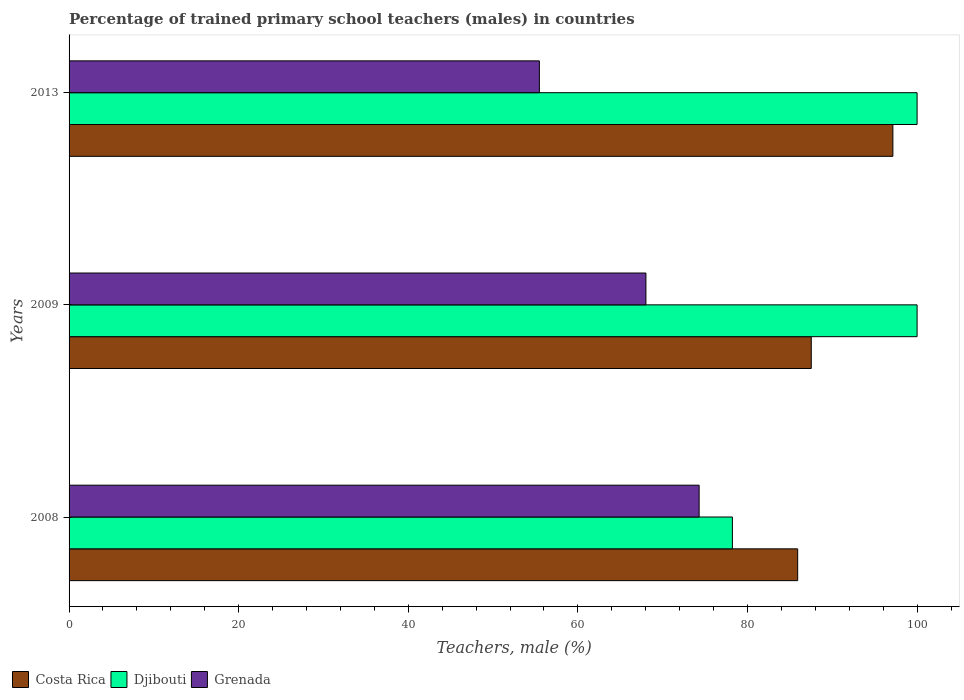How many groups of bars are there?
Your answer should be very brief. 3. Are the number of bars per tick equal to the number of legend labels?
Your response must be concise. Yes. In how many cases, is the number of bars for a given year not equal to the number of legend labels?
Your answer should be very brief. 0. What is the percentage of trained primary school teachers (males) in Costa Rica in 2009?
Make the answer very short. 87.52. Across all years, what is the maximum percentage of trained primary school teachers (males) in Grenada?
Offer a terse response. 74.3. Across all years, what is the minimum percentage of trained primary school teachers (males) in Djibouti?
Your answer should be compact. 78.22. In which year was the percentage of trained primary school teachers (males) in Djibouti maximum?
Keep it short and to the point. 2009. What is the total percentage of trained primary school teachers (males) in Costa Rica in the graph?
Ensure brevity in your answer.  270.58. What is the difference between the percentage of trained primary school teachers (males) in Costa Rica in 2008 and that in 2009?
Give a very brief answer. -1.6. What is the difference between the percentage of trained primary school teachers (males) in Costa Rica in 2009 and the percentage of trained primary school teachers (males) in Djibouti in 2008?
Offer a very short reply. 9.3. What is the average percentage of trained primary school teachers (males) in Costa Rica per year?
Provide a short and direct response. 90.19. In the year 2013, what is the difference between the percentage of trained primary school teachers (males) in Costa Rica and percentage of trained primary school teachers (males) in Grenada?
Provide a short and direct response. 41.68. What is the ratio of the percentage of trained primary school teachers (males) in Djibouti in 2008 to that in 2013?
Your response must be concise. 0.78. What is the difference between the highest and the lowest percentage of trained primary school teachers (males) in Costa Rica?
Provide a succinct answer. 11.23. In how many years, is the percentage of trained primary school teachers (males) in Costa Rica greater than the average percentage of trained primary school teachers (males) in Costa Rica taken over all years?
Your answer should be very brief. 1. What does the 2nd bar from the top in 2013 represents?
Give a very brief answer. Djibouti. What does the 2nd bar from the bottom in 2008 represents?
Make the answer very short. Djibouti. How many bars are there?
Make the answer very short. 9. What is the difference between two consecutive major ticks on the X-axis?
Your answer should be compact. 20. Does the graph contain any zero values?
Offer a very short reply. No. Does the graph contain grids?
Give a very brief answer. No. Where does the legend appear in the graph?
Keep it short and to the point. Bottom left. How many legend labels are there?
Keep it short and to the point. 3. How are the legend labels stacked?
Your answer should be compact. Horizontal. What is the title of the graph?
Your answer should be compact. Percentage of trained primary school teachers (males) in countries. What is the label or title of the X-axis?
Keep it short and to the point. Teachers, male (%). What is the label or title of the Y-axis?
Provide a short and direct response. Years. What is the Teachers, male (%) in Costa Rica in 2008?
Provide a succinct answer. 85.92. What is the Teachers, male (%) in Djibouti in 2008?
Make the answer very short. 78.22. What is the Teachers, male (%) in Grenada in 2008?
Your response must be concise. 74.3. What is the Teachers, male (%) in Costa Rica in 2009?
Provide a succinct answer. 87.52. What is the Teachers, male (%) of Djibouti in 2009?
Offer a terse response. 100. What is the Teachers, male (%) in Grenada in 2009?
Your answer should be very brief. 68.02. What is the Teachers, male (%) in Costa Rica in 2013?
Provide a succinct answer. 97.14. What is the Teachers, male (%) of Djibouti in 2013?
Make the answer very short. 100. What is the Teachers, male (%) in Grenada in 2013?
Your answer should be compact. 55.46. Across all years, what is the maximum Teachers, male (%) of Costa Rica?
Keep it short and to the point. 97.14. Across all years, what is the maximum Teachers, male (%) of Grenada?
Your answer should be very brief. 74.3. Across all years, what is the minimum Teachers, male (%) of Costa Rica?
Provide a succinct answer. 85.92. Across all years, what is the minimum Teachers, male (%) of Djibouti?
Provide a succinct answer. 78.22. Across all years, what is the minimum Teachers, male (%) of Grenada?
Make the answer very short. 55.46. What is the total Teachers, male (%) in Costa Rica in the graph?
Your response must be concise. 270.58. What is the total Teachers, male (%) in Djibouti in the graph?
Your answer should be compact. 278.22. What is the total Teachers, male (%) of Grenada in the graph?
Provide a succinct answer. 197.78. What is the difference between the Teachers, male (%) in Costa Rica in 2008 and that in 2009?
Keep it short and to the point. -1.6. What is the difference between the Teachers, male (%) of Djibouti in 2008 and that in 2009?
Ensure brevity in your answer.  -21.78. What is the difference between the Teachers, male (%) of Grenada in 2008 and that in 2009?
Your answer should be compact. 6.27. What is the difference between the Teachers, male (%) in Costa Rica in 2008 and that in 2013?
Provide a short and direct response. -11.23. What is the difference between the Teachers, male (%) in Djibouti in 2008 and that in 2013?
Ensure brevity in your answer.  -21.78. What is the difference between the Teachers, male (%) in Grenada in 2008 and that in 2013?
Provide a succinct answer. 18.84. What is the difference between the Teachers, male (%) of Costa Rica in 2009 and that in 2013?
Give a very brief answer. -9.62. What is the difference between the Teachers, male (%) in Djibouti in 2009 and that in 2013?
Ensure brevity in your answer.  0. What is the difference between the Teachers, male (%) in Grenada in 2009 and that in 2013?
Offer a very short reply. 12.56. What is the difference between the Teachers, male (%) in Costa Rica in 2008 and the Teachers, male (%) in Djibouti in 2009?
Offer a terse response. -14.08. What is the difference between the Teachers, male (%) in Costa Rica in 2008 and the Teachers, male (%) in Grenada in 2009?
Your answer should be compact. 17.89. What is the difference between the Teachers, male (%) in Djibouti in 2008 and the Teachers, male (%) in Grenada in 2009?
Your response must be concise. 10.2. What is the difference between the Teachers, male (%) of Costa Rica in 2008 and the Teachers, male (%) of Djibouti in 2013?
Your answer should be compact. -14.08. What is the difference between the Teachers, male (%) in Costa Rica in 2008 and the Teachers, male (%) in Grenada in 2013?
Your answer should be compact. 30.46. What is the difference between the Teachers, male (%) of Djibouti in 2008 and the Teachers, male (%) of Grenada in 2013?
Keep it short and to the point. 22.76. What is the difference between the Teachers, male (%) of Costa Rica in 2009 and the Teachers, male (%) of Djibouti in 2013?
Your answer should be compact. -12.48. What is the difference between the Teachers, male (%) of Costa Rica in 2009 and the Teachers, male (%) of Grenada in 2013?
Your answer should be very brief. 32.06. What is the difference between the Teachers, male (%) in Djibouti in 2009 and the Teachers, male (%) in Grenada in 2013?
Ensure brevity in your answer.  44.54. What is the average Teachers, male (%) of Costa Rica per year?
Provide a short and direct response. 90.19. What is the average Teachers, male (%) in Djibouti per year?
Ensure brevity in your answer.  92.74. What is the average Teachers, male (%) of Grenada per year?
Keep it short and to the point. 65.93. In the year 2008, what is the difference between the Teachers, male (%) in Costa Rica and Teachers, male (%) in Djibouti?
Your answer should be compact. 7.7. In the year 2008, what is the difference between the Teachers, male (%) of Costa Rica and Teachers, male (%) of Grenada?
Your answer should be very brief. 11.62. In the year 2008, what is the difference between the Teachers, male (%) in Djibouti and Teachers, male (%) in Grenada?
Provide a short and direct response. 3.92. In the year 2009, what is the difference between the Teachers, male (%) in Costa Rica and Teachers, male (%) in Djibouti?
Your answer should be compact. -12.48. In the year 2009, what is the difference between the Teachers, male (%) of Costa Rica and Teachers, male (%) of Grenada?
Offer a very short reply. 19.5. In the year 2009, what is the difference between the Teachers, male (%) of Djibouti and Teachers, male (%) of Grenada?
Make the answer very short. 31.98. In the year 2013, what is the difference between the Teachers, male (%) of Costa Rica and Teachers, male (%) of Djibouti?
Offer a very short reply. -2.86. In the year 2013, what is the difference between the Teachers, male (%) in Costa Rica and Teachers, male (%) in Grenada?
Your answer should be compact. 41.68. In the year 2013, what is the difference between the Teachers, male (%) in Djibouti and Teachers, male (%) in Grenada?
Keep it short and to the point. 44.54. What is the ratio of the Teachers, male (%) of Costa Rica in 2008 to that in 2009?
Your response must be concise. 0.98. What is the ratio of the Teachers, male (%) in Djibouti in 2008 to that in 2009?
Provide a short and direct response. 0.78. What is the ratio of the Teachers, male (%) of Grenada in 2008 to that in 2009?
Offer a terse response. 1.09. What is the ratio of the Teachers, male (%) in Costa Rica in 2008 to that in 2013?
Offer a terse response. 0.88. What is the ratio of the Teachers, male (%) of Djibouti in 2008 to that in 2013?
Your answer should be very brief. 0.78. What is the ratio of the Teachers, male (%) in Grenada in 2008 to that in 2013?
Make the answer very short. 1.34. What is the ratio of the Teachers, male (%) in Costa Rica in 2009 to that in 2013?
Offer a terse response. 0.9. What is the ratio of the Teachers, male (%) of Djibouti in 2009 to that in 2013?
Provide a short and direct response. 1. What is the ratio of the Teachers, male (%) of Grenada in 2009 to that in 2013?
Keep it short and to the point. 1.23. What is the difference between the highest and the second highest Teachers, male (%) of Costa Rica?
Keep it short and to the point. 9.62. What is the difference between the highest and the second highest Teachers, male (%) of Djibouti?
Offer a very short reply. 0. What is the difference between the highest and the second highest Teachers, male (%) in Grenada?
Your answer should be very brief. 6.27. What is the difference between the highest and the lowest Teachers, male (%) in Costa Rica?
Your answer should be compact. 11.23. What is the difference between the highest and the lowest Teachers, male (%) in Djibouti?
Offer a very short reply. 21.78. What is the difference between the highest and the lowest Teachers, male (%) in Grenada?
Keep it short and to the point. 18.84. 